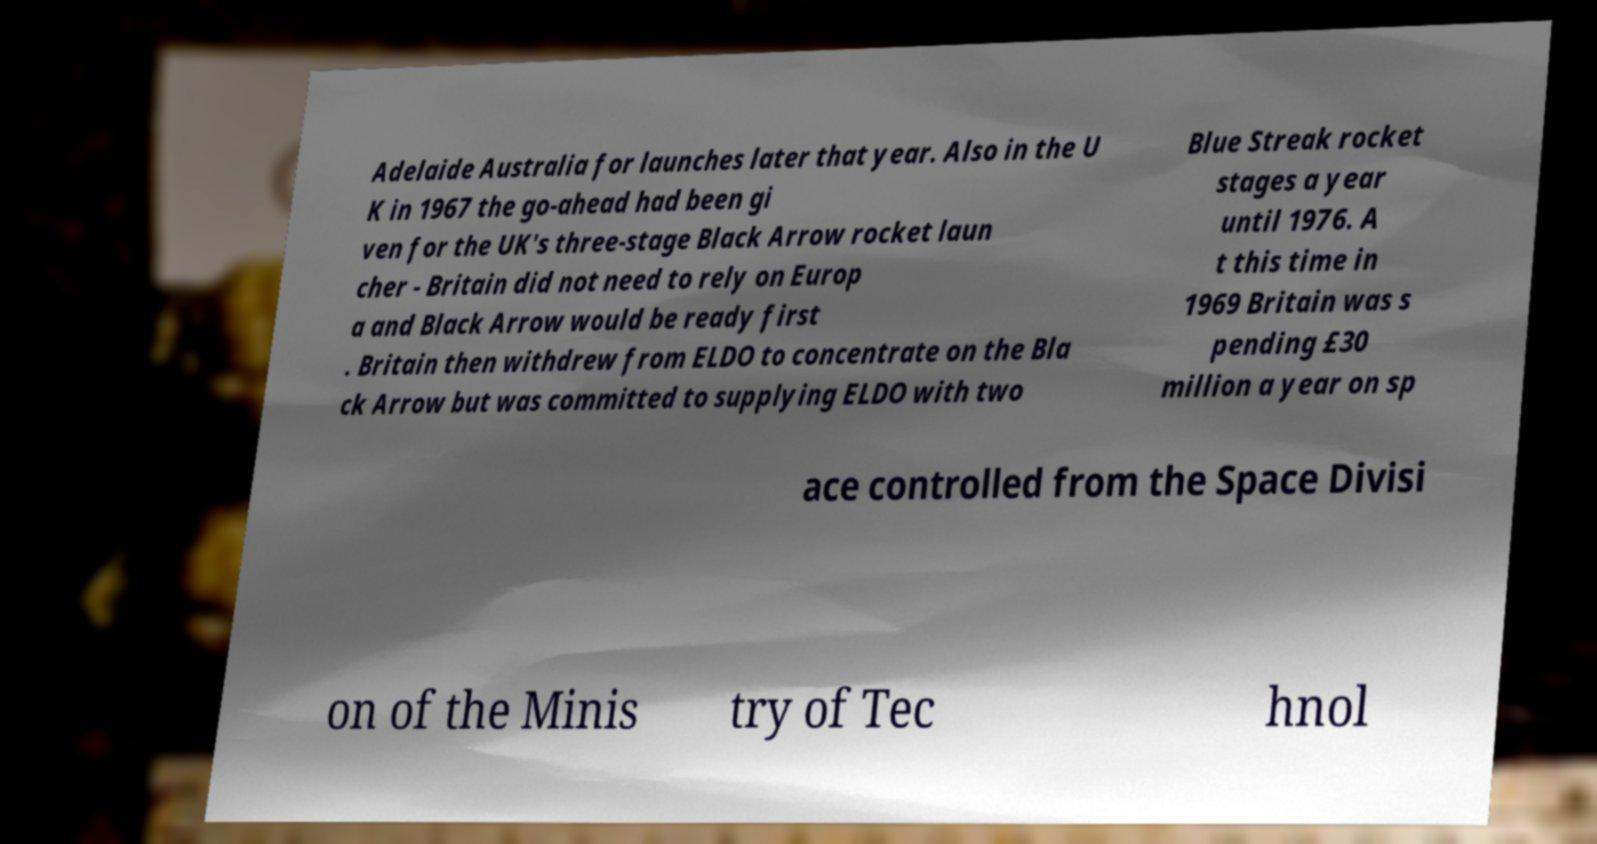Please read and relay the text visible in this image. What does it say? Adelaide Australia for launches later that year. Also in the U K in 1967 the go-ahead had been gi ven for the UK's three-stage Black Arrow rocket laun cher - Britain did not need to rely on Europ a and Black Arrow would be ready first . Britain then withdrew from ELDO to concentrate on the Bla ck Arrow but was committed to supplying ELDO with two Blue Streak rocket stages a year until 1976. A t this time in 1969 Britain was s pending £30 million a year on sp ace controlled from the Space Divisi on of the Minis try of Tec hnol 